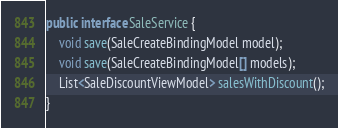Convert code to text. <code><loc_0><loc_0><loc_500><loc_500><_Java_>
public interface SaleService {
    void save(SaleCreateBindingModel model);
    void save(SaleCreateBindingModel[] models);
    List<SaleDiscountViewModel> salesWithDiscount();
}
</code> 